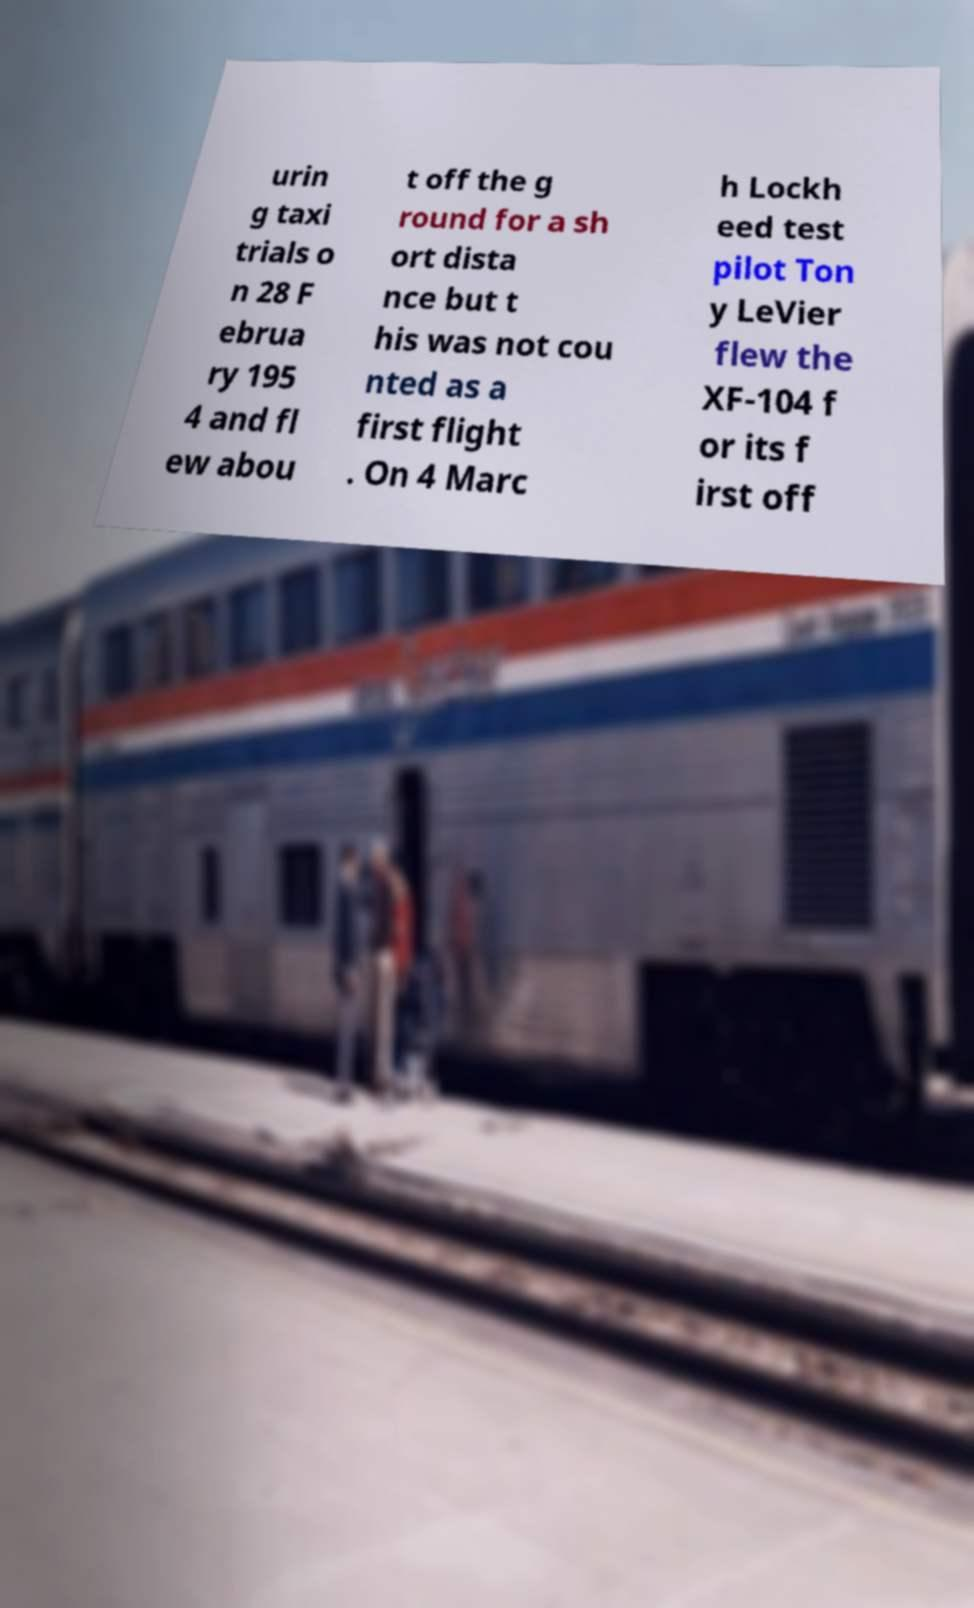Could you extract and type out the text from this image? urin g taxi trials o n 28 F ebrua ry 195 4 and fl ew abou t off the g round for a sh ort dista nce but t his was not cou nted as a first flight . On 4 Marc h Lockh eed test pilot Ton y LeVier flew the XF-104 f or its f irst off 